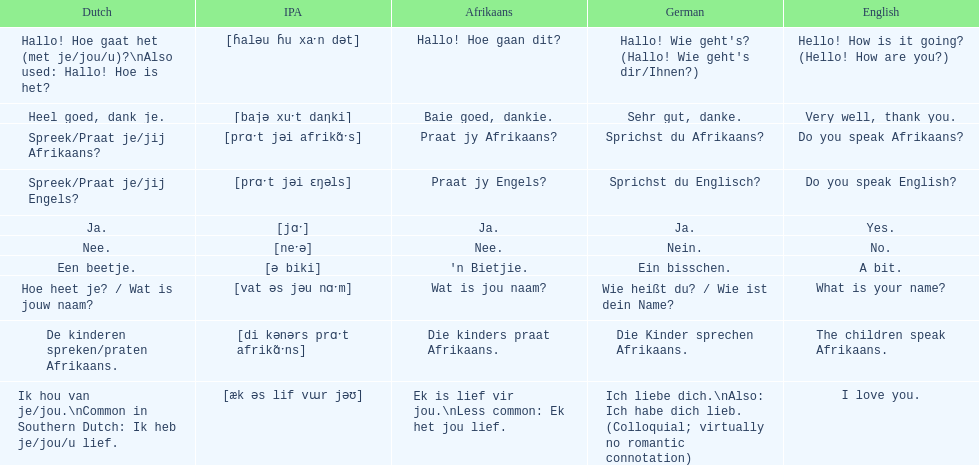How do you say 'yes' in afrikaans? Ja. 